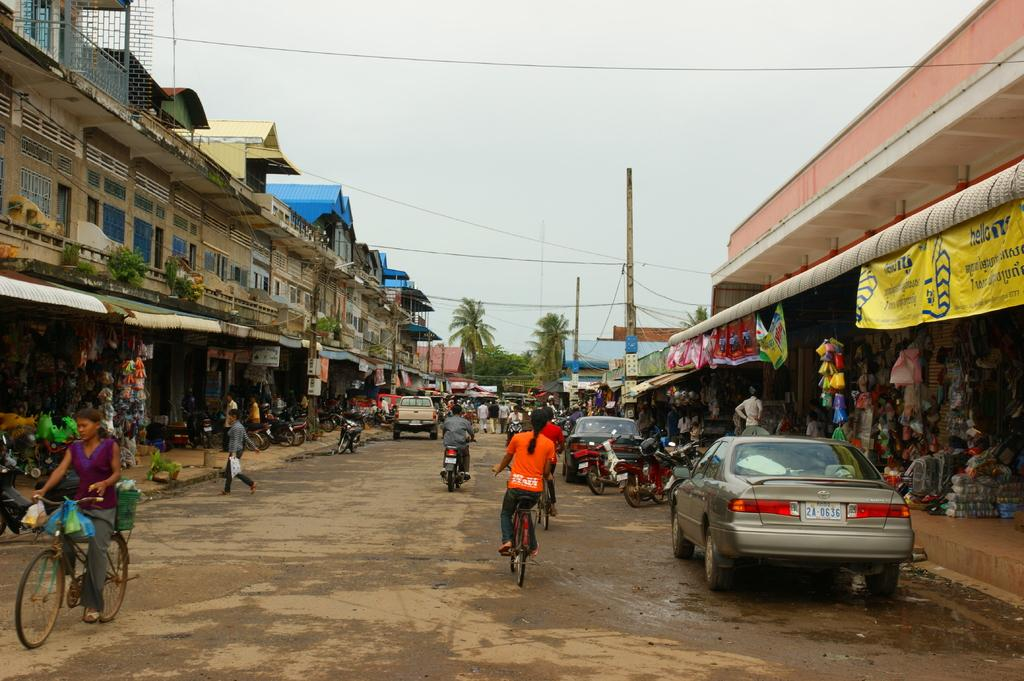What type of structures can be seen in the image? There are buildings in the image. What additional elements are present in the image? There are banners, trees, cars, motorcycles, bicycles, and people in the image. What can be seen in the sky in the image? The sky is visible at the top of the image. Can you tell me how many crackers are hanging from the trees in the image? There are no crackers present in the image; it features buildings, banners, trees, cars, motorcycles, bicycles, and people. What type of stocking is being worn by the person on the motorcycle in the image? There is no person on a motorcycle in the image, and therefore no stocking can be observed. 